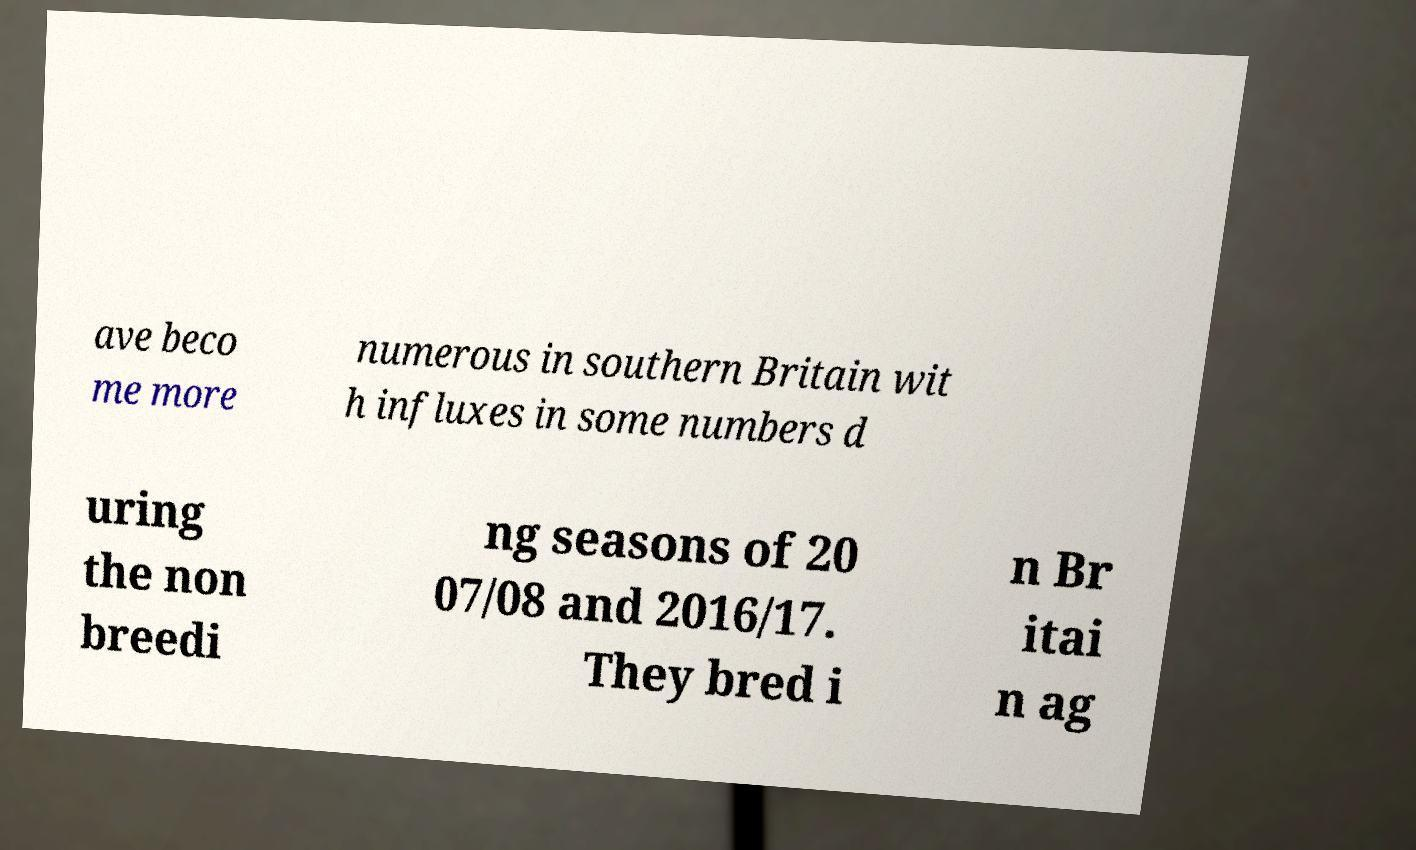Please read and relay the text visible in this image. What does it say? ave beco me more numerous in southern Britain wit h influxes in some numbers d uring the non breedi ng seasons of 20 07/08 and 2016/17. They bred i n Br itai n ag 